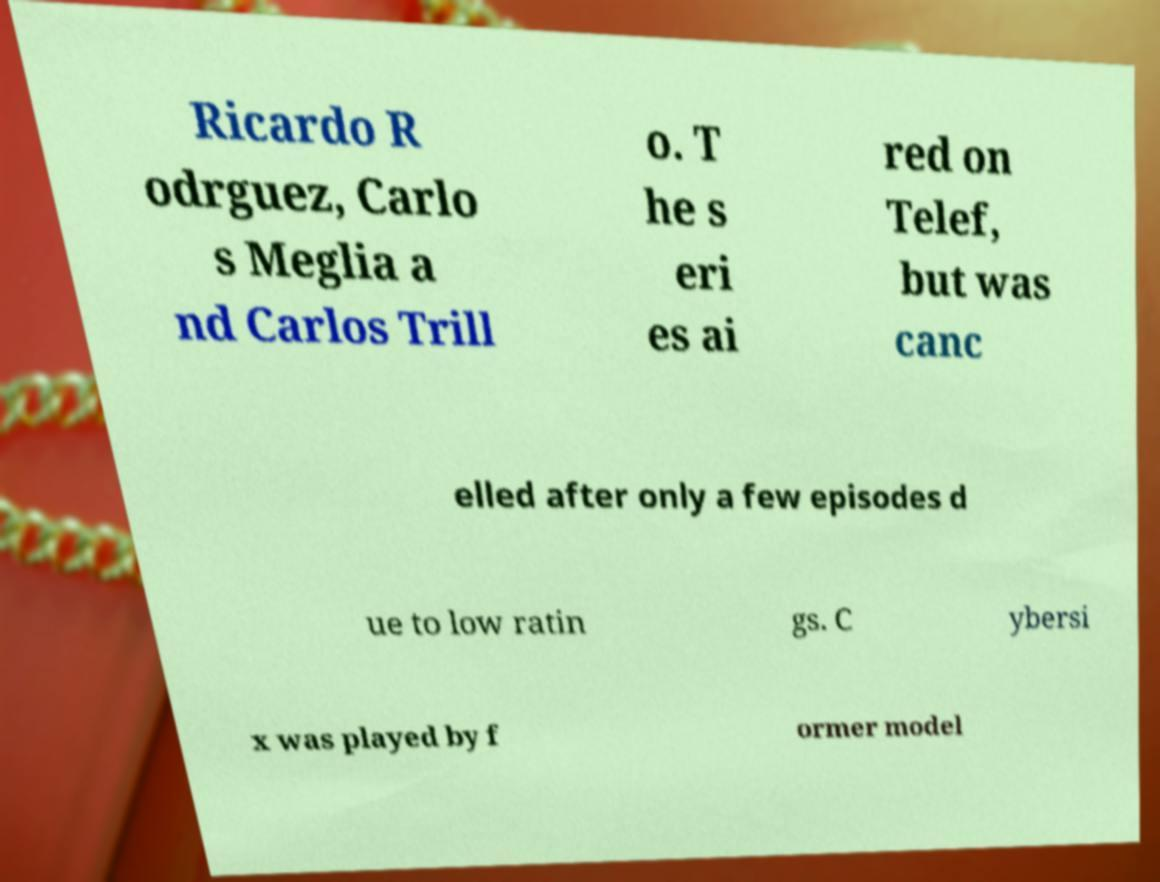What messages or text are displayed in this image? I need them in a readable, typed format. Ricardo R odrguez, Carlo s Meglia a nd Carlos Trill o. T he s eri es ai red on Telef, but was canc elled after only a few episodes d ue to low ratin gs. C ybersi x was played by f ormer model 